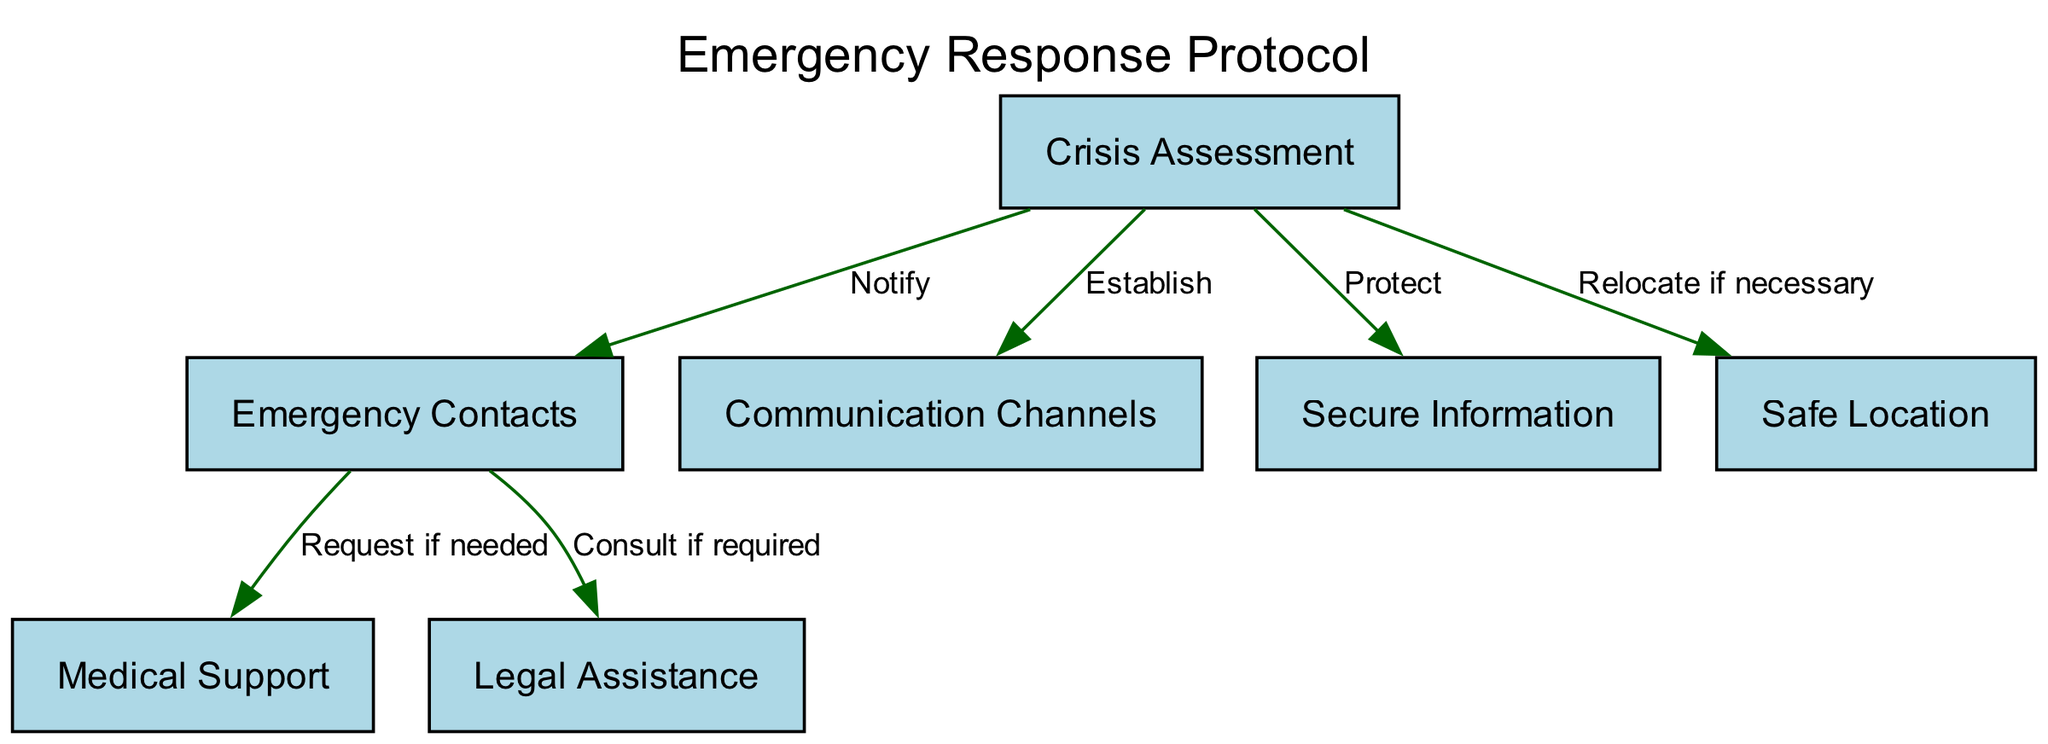What is the first step in the emergency response protocol? The first step in the protocol is "Crisis Assessment," which is the initial node in the diagram that starts the response process.
Answer: Crisis Assessment How many nodes are present in the diagram? By counting the nodes listed in the data, a total of seven nodes can be identified: Crisis Assessment, Emergency Contacts, Communication Channels, Secure Information, Safe Location, Medical Support, and Legal Assistance.
Answer: 7 What action is taken after "Crisis Assessment"? The next actions from the "Crisis Assessment" node lead to notifying "Emergency Contacts," establishing "Communication Channels," protecting "Secure Information," and relocating if necessary to a "Safe Location." Two common actions are to notify Emergency Contacts or establish Communication Channels.
Answer: Notify Which node provides legal help? The node that provides legal help is "Legal Assistance," which is directly linked to the "Emergency Contacts" node, indicating a relationship where legal support can be consulted if required.
Answer: Legal Assistance What are the two types of support requested from "Emergency Contacts"? From the "Emergency Contacts" node, the two types of support that can be requested are "Medical Support" if needed and "Legal Assistance" if required. These are the two direct actions stemming from Emergency Contacts.
Answer: Medical Support and Legal Assistance What is the label on the edge connecting "Crisis Assessment" to "Secure Information"? The edge between "Crisis Assessment" and "Secure Information" is labeled "Protect," indicating the action taken to ensure the information remains secure during a crisis response.
Answer: Protect What happens if "Emergency Contacts" are notified? Once "Emergency Contacts" are notified, one can request "Medical Support" if needed or consult "Legal Assistance" if required, indicating that notifying Emergency Contacts triggers these two avenues of support.
Answer: Request Medical Support or Consult Legal Assistance How many total edges are depicted in the diagram? The edges connect various nodes, and upon counting them from the data provided, there are a total of six edges linking the nodes together, indicating the actions taken between them.
Answer: 6 